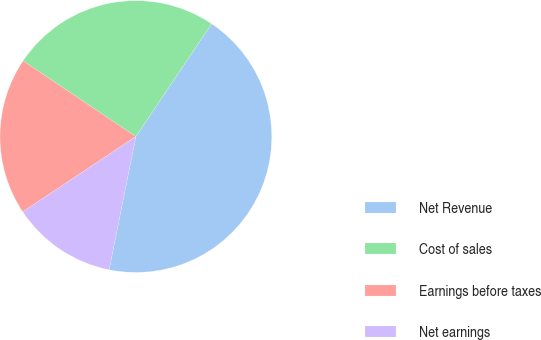Convert chart to OTSL. <chart><loc_0><loc_0><loc_500><loc_500><pie_chart><fcel>Net Revenue<fcel>Cost of sales<fcel>Earnings before taxes<fcel>Net earnings<nl><fcel>43.75%<fcel>25.0%<fcel>18.75%<fcel>12.5%<nl></chart> 